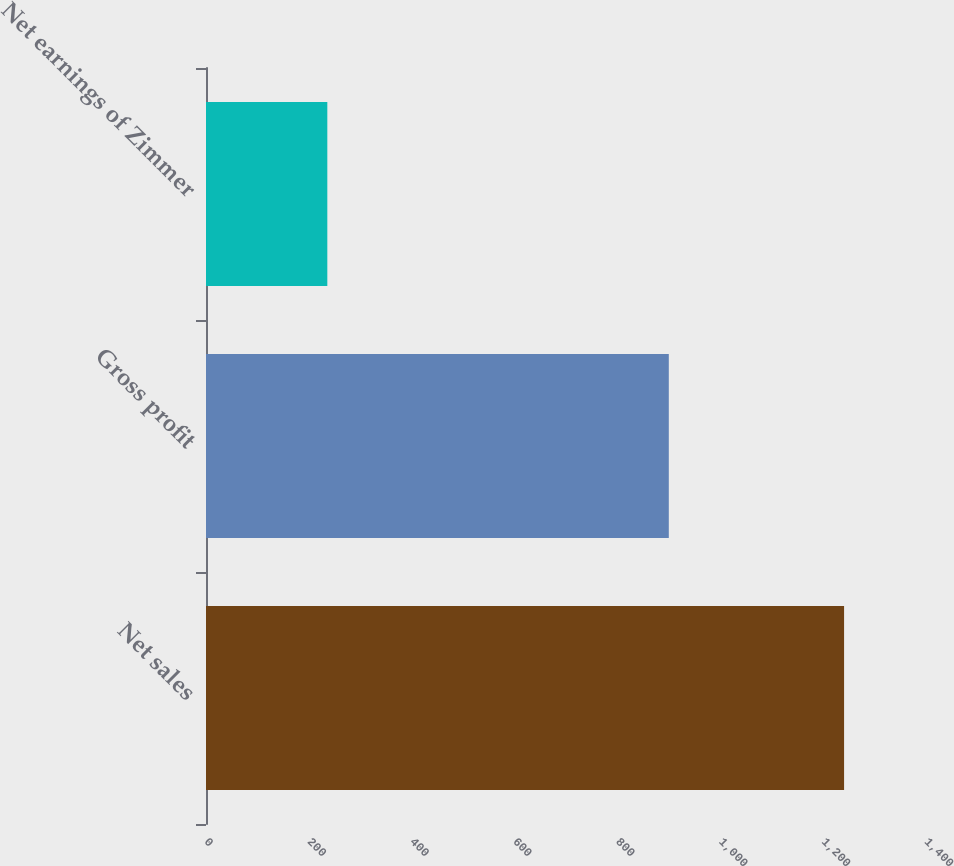Convert chart. <chart><loc_0><loc_0><loc_500><loc_500><bar_chart><fcel>Net sales<fcel>Gross profit<fcel>Net earnings of Zimmer<nl><fcel>1240.7<fcel>899.9<fcel>235.9<nl></chart> 